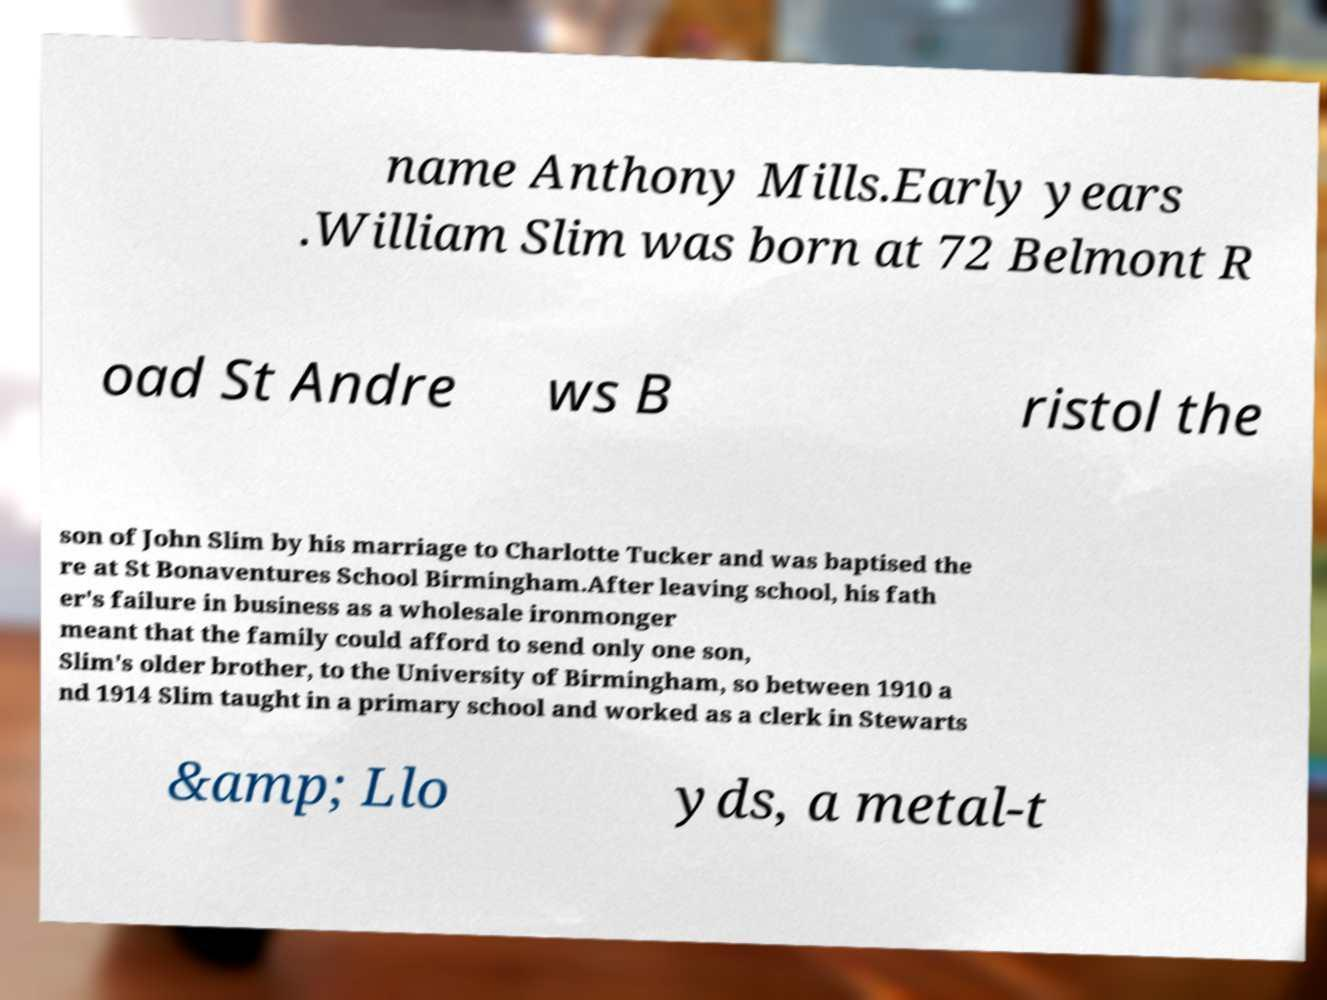For documentation purposes, I need the text within this image transcribed. Could you provide that? name Anthony Mills.Early years .William Slim was born at 72 Belmont R oad St Andre ws B ristol the son of John Slim by his marriage to Charlotte Tucker and was baptised the re at St Bonaventures School Birmingham.After leaving school, his fath er's failure in business as a wholesale ironmonger meant that the family could afford to send only one son, Slim's older brother, to the University of Birmingham, so between 1910 a nd 1914 Slim taught in a primary school and worked as a clerk in Stewarts &amp; Llo yds, a metal-t 